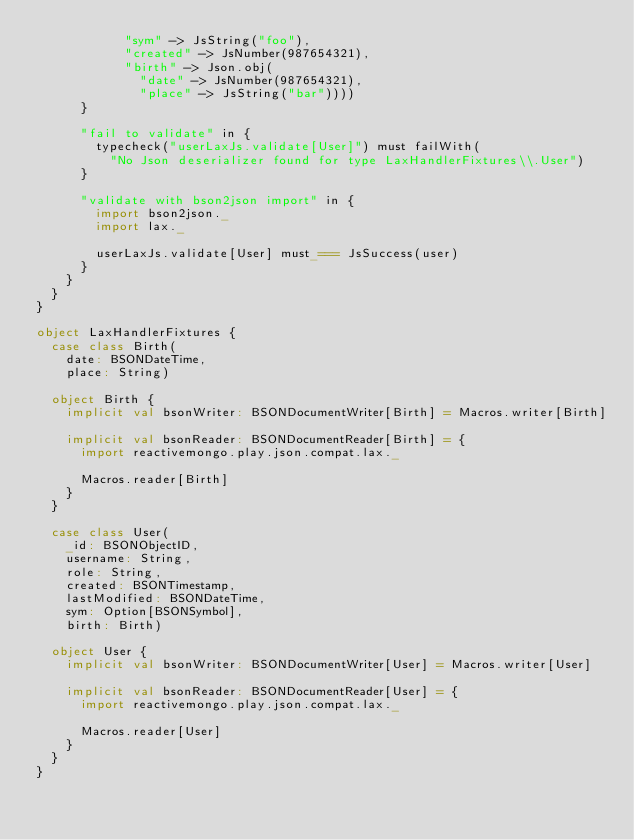Convert code to text. <code><loc_0><loc_0><loc_500><loc_500><_Scala_>            "sym" -> JsString("foo"),
            "created" -> JsNumber(987654321),
            "birth" -> Json.obj(
              "date" -> JsNumber(987654321),
              "place" -> JsString("bar"))))
      }

      "fail to validate" in {
        typecheck("userLaxJs.validate[User]") must failWith(
          "No Json deserializer found for type LaxHandlerFixtures\\.User")
      }

      "validate with bson2json import" in {
        import bson2json._
        import lax._

        userLaxJs.validate[User] must_=== JsSuccess(user)
      }
    }
  }
}

object LaxHandlerFixtures {
  case class Birth(
    date: BSONDateTime,
    place: String)

  object Birth {
    implicit val bsonWriter: BSONDocumentWriter[Birth] = Macros.writer[Birth]

    implicit val bsonReader: BSONDocumentReader[Birth] = {
      import reactivemongo.play.json.compat.lax._

      Macros.reader[Birth]
    }
  }

  case class User(
    _id: BSONObjectID,
    username: String,
    role: String,
    created: BSONTimestamp,
    lastModified: BSONDateTime,
    sym: Option[BSONSymbol],
    birth: Birth)

  object User {
    implicit val bsonWriter: BSONDocumentWriter[User] = Macros.writer[User]

    implicit val bsonReader: BSONDocumentReader[User] = {
      import reactivemongo.play.json.compat.lax._

      Macros.reader[User]
    }
  }
}
</code> 